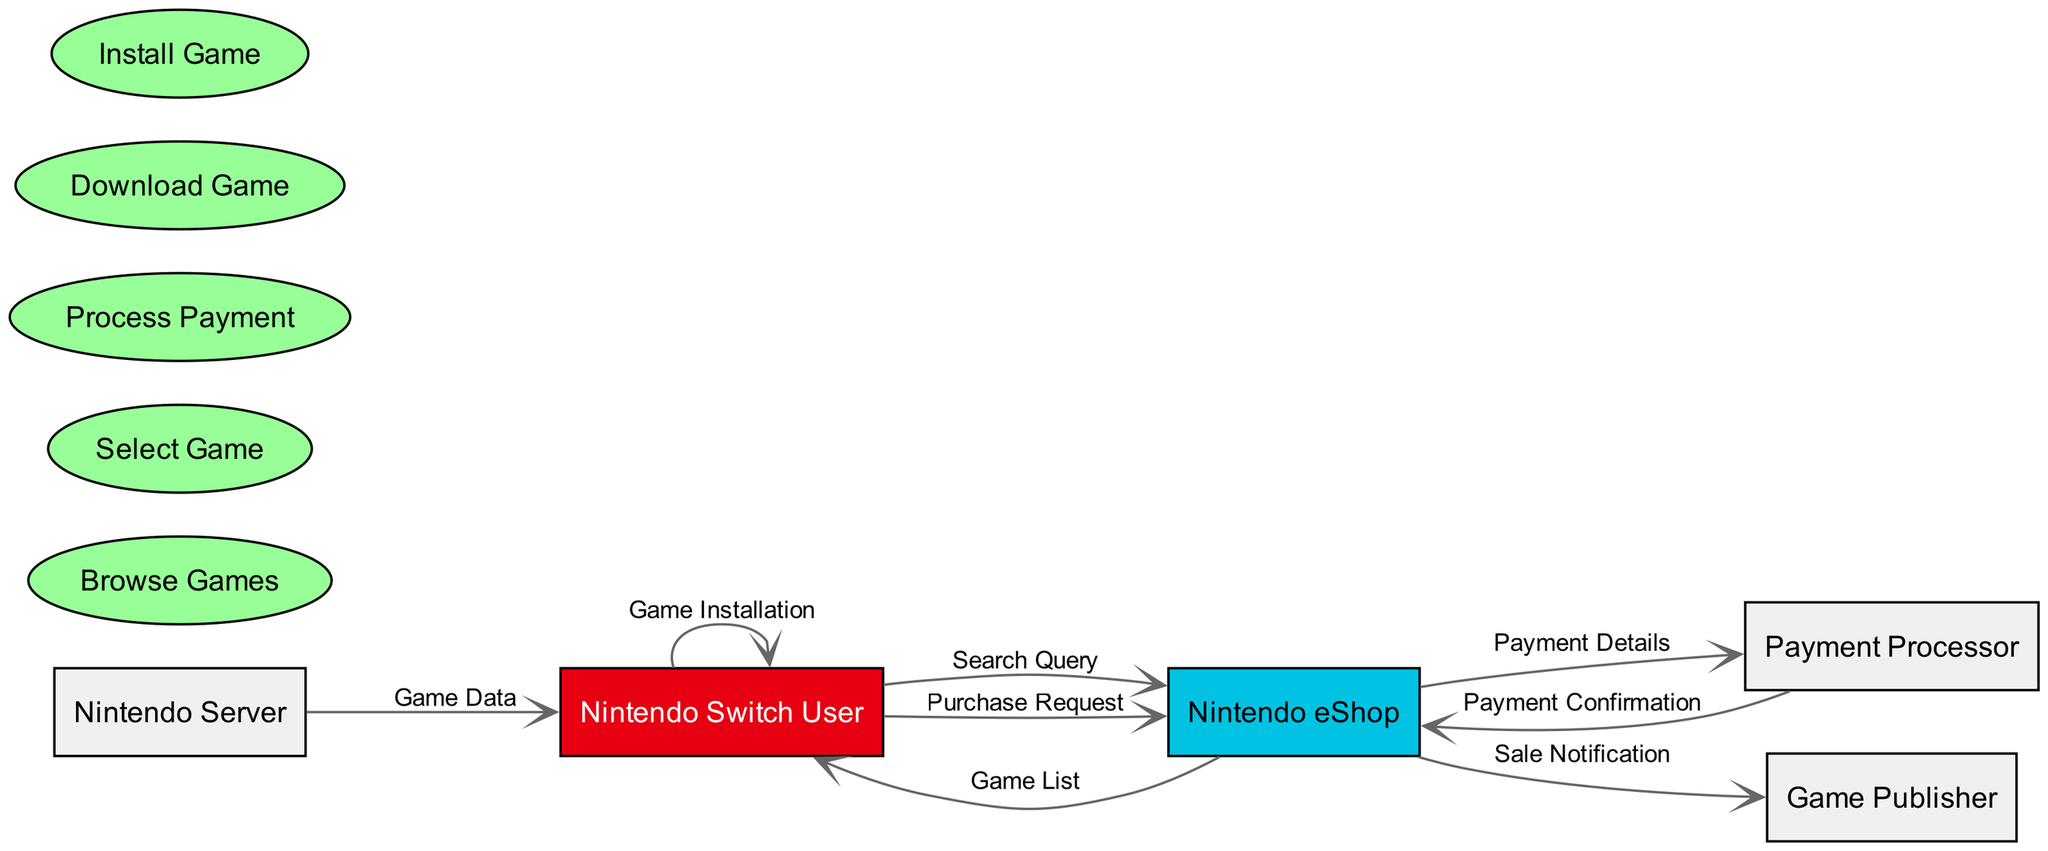What is the primary user entity in this diagram? The diagram identifies "Nintendo Switch User" as the primary user entity, as it appears at the start of various transactions and interacts directly with multiple components such as the eShop and server.
Answer: Nintendo Switch User How many data flows originate from the Nintendo eShop? By examining the diagram, I can see that there are four data flows that originate from the Nintendo eShop: "Game List," "Payment Details," "Sale Notification," and "Game Data" directed to the corresponding entities.
Answer: Four What type of node is used to represent processes in the diagram? The diagram uses ellipse-shape nodes filled in a specific color to denote processes, distinguishing them clearly from entities that are represented using rectangles.
Answer: Ellipse Which entity receives payment confirmation after processing payment? The "Payment Processor" sends back a "Payment Confirmation" to the "Nintendo eShop," making it the entity that receives this confirmation in the flow.
Answer: Nintendo eShop What action follows after the user selects a game? According to the flow, after selecting a game, the next action is to process payment, indicated by the transition from the "Select Game" process to the "Process Payment" process.
Answer: Process Payment How does the game installation process occur in the flow? The diagram shows that after the user downloads the game data from the "Nintendo Server," the installation occurs as a self-directed flow from the "Nintendo Switch User" back to itself, indicating the user's control over this action.
Answer: Game Installation What happens to the sale notification once the payment is confirmed? Once payment is confirmed, the condition from the "Payment Processor" triggers the "Sale Notification" to be sent from the "Nintendo eShop" to the "Game Publisher," indicating that a sale has occurred.
Answer: Sale Notification Which node acts as the final destination for game data? The final destination for the game data is the "Nintendo Switch User," as the "Nintendo Server" sends the "Game Data" directly to this user entity.
Answer: Nintendo Switch User 